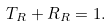Convert formula to latex. <formula><loc_0><loc_0><loc_500><loc_500>T _ { R } + R _ { R } = 1 .</formula> 